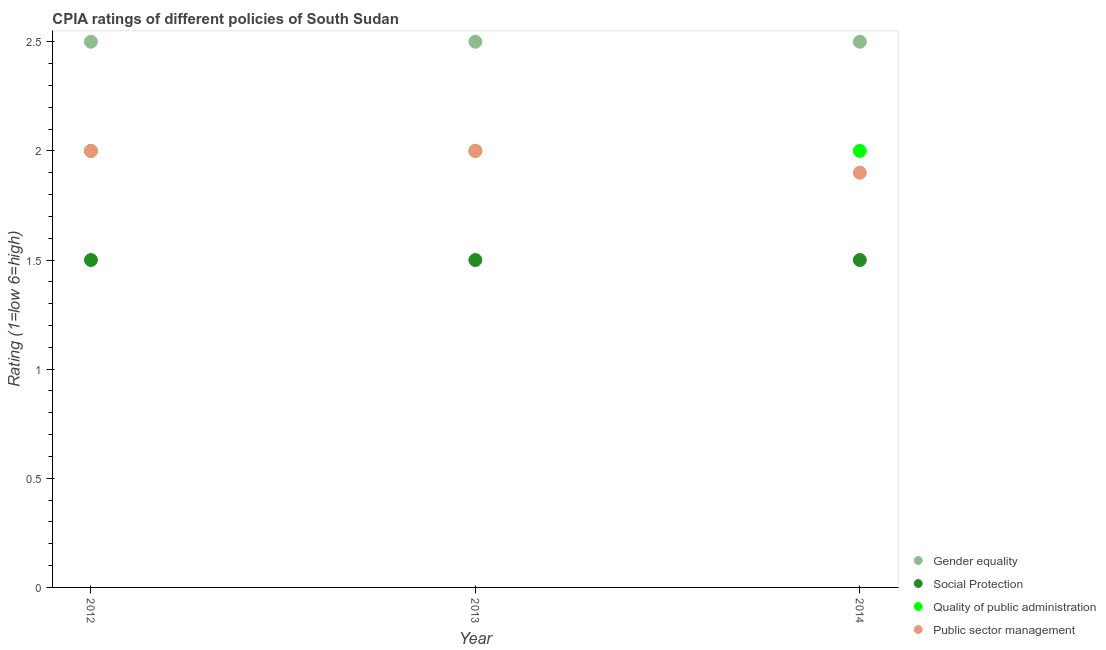How many different coloured dotlines are there?
Give a very brief answer. 4. Is the number of dotlines equal to the number of legend labels?
Offer a very short reply. Yes. What is the cpia rating of quality of public administration in 2012?
Provide a succinct answer. 2. Across all years, what is the maximum cpia rating of quality of public administration?
Make the answer very short. 2. Across all years, what is the minimum cpia rating of social protection?
Provide a succinct answer. 1.5. In which year was the cpia rating of gender equality minimum?
Offer a terse response. 2012. What is the total cpia rating of public sector management in the graph?
Ensure brevity in your answer.  5.9. What is the difference between the cpia rating of public sector management in 2012 and that in 2013?
Your answer should be compact. 0. What is the difference between the cpia rating of public sector management in 2014 and the cpia rating of quality of public administration in 2013?
Provide a succinct answer. -0.1. What is the average cpia rating of public sector management per year?
Your answer should be very brief. 1.97. What is the ratio of the cpia rating of gender equality in 2013 to that in 2014?
Provide a short and direct response. 1. Is the difference between the cpia rating of gender equality in 2012 and 2013 greater than the difference between the cpia rating of social protection in 2012 and 2013?
Your response must be concise. No. What is the difference between the highest and the second highest cpia rating of public sector management?
Ensure brevity in your answer.  0. In how many years, is the cpia rating of public sector management greater than the average cpia rating of public sector management taken over all years?
Your answer should be very brief. 2. Is it the case that in every year, the sum of the cpia rating of public sector management and cpia rating of quality of public administration is greater than the sum of cpia rating of social protection and cpia rating of gender equality?
Offer a terse response. Yes. Is the cpia rating of public sector management strictly less than the cpia rating of social protection over the years?
Provide a short and direct response. No. How many dotlines are there?
Make the answer very short. 4. How many years are there in the graph?
Your answer should be very brief. 3. Where does the legend appear in the graph?
Keep it short and to the point. Bottom right. How many legend labels are there?
Offer a very short reply. 4. How are the legend labels stacked?
Offer a very short reply. Vertical. What is the title of the graph?
Offer a terse response. CPIA ratings of different policies of South Sudan. Does "Australia" appear as one of the legend labels in the graph?
Make the answer very short. No. What is the label or title of the X-axis?
Your response must be concise. Year. What is the Rating (1=low 6=high) of Quality of public administration in 2012?
Offer a terse response. 2. What is the Rating (1=low 6=high) in Public sector management in 2012?
Offer a very short reply. 2. What is the Rating (1=low 6=high) in Social Protection in 2013?
Offer a terse response. 1.5. What is the Rating (1=low 6=high) of Public sector management in 2013?
Give a very brief answer. 2. What is the Rating (1=low 6=high) in Gender equality in 2014?
Your response must be concise. 2.5. What is the Rating (1=low 6=high) in Social Protection in 2014?
Your response must be concise. 1.5. What is the Rating (1=low 6=high) in Quality of public administration in 2014?
Provide a short and direct response. 2. What is the Rating (1=low 6=high) in Public sector management in 2014?
Provide a short and direct response. 1.9. Across all years, what is the minimum Rating (1=low 6=high) of Gender equality?
Provide a succinct answer. 2.5. Across all years, what is the minimum Rating (1=low 6=high) of Social Protection?
Keep it short and to the point. 1.5. Across all years, what is the minimum Rating (1=low 6=high) in Quality of public administration?
Ensure brevity in your answer.  2. What is the total Rating (1=low 6=high) of Social Protection in the graph?
Provide a short and direct response. 4.5. What is the total Rating (1=low 6=high) in Public sector management in the graph?
Give a very brief answer. 5.9. What is the difference between the Rating (1=low 6=high) of Social Protection in 2012 and that in 2013?
Your answer should be very brief. 0. What is the difference between the Rating (1=low 6=high) of Quality of public administration in 2012 and that in 2013?
Make the answer very short. 0. What is the difference between the Rating (1=low 6=high) of Public sector management in 2012 and that in 2013?
Your answer should be very brief. 0. What is the difference between the Rating (1=low 6=high) of Social Protection in 2012 and that in 2014?
Keep it short and to the point. 0. What is the difference between the Rating (1=low 6=high) in Quality of public administration in 2012 and that in 2014?
Your response must be concise. 0. What is the difference between the Rating (1=low 6=high) of Gender equality in 2013 and that in 2014?
Give a very brief answer. 0. What is the difference between the Rating (1=low 6=high) in Social Protection in 2013 and that in 2014?
Offer a terse response. 0. What is the difference between the Rating (1=low 6=high) of Public sector management in 2013 and that in 2014?
Your answer should be very brief. 0.1. What is the difference between the Rating (1=low 6=high) in Gender equality in 2012 and the Rating (1=low 6=high) in Quality of public administration in 2013?
Provide a succinct answer. 0.5. What is the difference between the Rating (1=low 6=high) in Gender equality in 2012 and the Rating (1=low 6=high) in Public sector management in 2013?
Ensure brevity in your answer.  0.5. What is the difference between the Rating (1=low 6=high) of Social Protection in 2012 and the Rating (1=low 6=high) of Quality of public administration in 2013?
Your response must be concise. -0.5. What is the difference between the Rating (1=low 6=high) in Quality of public administration in 2012 and the Rating (1=low 6=high) in Public sector management in 2013?
Provide a short and direct response. 0. What is the difference between the Rating (1=low 6=high) in Gender equality in 2012 and the Rating (1=low 6=high) in Social Protection in 2014?
Offer a terse response. 1. What is the difference between the Rating (1=low 6=high) in Gender equality in 2012 and the Rating (1=low 6=high) in Public sector management in 2014?
Make the answer very short. 0.6. What is the difference between the Rating (1=low 6=high) of Quality of public administration in 2012 and the Rating (1=low 6=high) of Public sector management in 2014?
Offer a very short reply. 0.1. What is the difference between the Rating (1=low 6=high) of Social Protection in 2013 and the Rating (1=low 6=high) of Quality of public administration in 2014?
Offer a very short reply. -0.5. What is the average Rating (1=low 6=high) in Gender equality per year?
Give a very brief answer. 2.5. What is the average Rating (1=low 6=high) in Social Protection per year?
Offer a terse response. 1.5. What is the average Rating (1=low 6=high) in Quality of public administration per year?
Keep it short and to the point. 2. What is the average Rating (1=low 6=high) of Public sector management per year?
Ensure brevity in your answer.  1.97. In the year 2012, what is the difference between the Rating (1=low 6=high) of Gender equality and Rating (1=low 6=high) of Quality of public administration?
Give a very brief answer. 0.5. In the year 2012, what is the difference between the Rating (1=low 6=high) in Gender equality and Rating (1=low 6=high) in Public sector management?
Give a very brief answer. 0.5. In the year 2012, what is the difference between the Rating (1=low 6=high) in Social Protection and Rating (1=low 6=high) in Quality of public administration?
Give a very brief answer. -0.5. In the year 2013, what is the difference between the Rating (1=low 6=high) of Quality of public administration and Rating (1=low 6=high) of Public sector management?
Offer a terse response. 0. In the year 2014, what is the difference between the Rating (1=low 6=high) in Gender equality and Rating (1=low 6=high) in Quality of public administration?
Your response must be concise. 0.5. In the year 2014, what is the difference between the Rating (1=low 6=high) of Gender equality and Rating (1=low 6=high) of Public sector management?
Give a very brief answer. 0.6. In the year 2014, what is the difference between the Rating (1=low 6=high) in Social Protection and Rating (1=low 6=high) in Quality of public administration?
Your answer should be very brief. -0.5. In the year 2014, what is the difference between the Rating (1=low 6=high) of Social Protection and Rating (1=low 6=high) of Public sector management?
Your answer should be very brief. -0.4. What is the ratio of the Rating (1=low 6=high) of Gender equality in 2012 to that in 2013?
Make the answer very short. 1. What is the ratio of the Rating (1=low 6=high) in Public sector management in 2012 to that in 2013?
Provide a short and direct response. 1. What is the ratio of the Rating (1=low 6=high) in Gender equality in 2012 to that in 2014?
Your answer should be very brief. 1. What is the ratio of the Rating (1=low 6=high) of Social Protection in 2012 to that in 2014?
Give a very brief answer. 1. What is the ratio of the Rating (1=low 6=high) in Public sector management in 2012 to that in 2014?
Your answer should be compact. 1.05. What is the ratio of the Rating (1=low 6=high) of Gender equality in 2013 to that in 2014?
Keep it short and to the point. 1. What is the ratio of the Rating (1=low 6=high) of Quality of public administration in 2013 to that in 2014?
Offer a terse response. 1. What is the ratio of the Rating (1=low 6=high) of Public sector management in 2013 to that in 2014?
Provide a succinct answer. 1.05. What is the difference between the highest and the second highest Rating (1=low 6=high) in Social Protection?
Provide a short and direct response. 0. What is the difference between the highest and the second highest Rating (1=low 6=high) in Quality of public administration?
Your response must be concise. 0. What is the difference between the highest and the lowest Rating (1=low 6=high) in Gender equality?
Your answer should be very brief. 0. What is the difference between the highest and the lowest Rating (1=low 6=high) in Social Protection?
Make the answer very short. 0. 